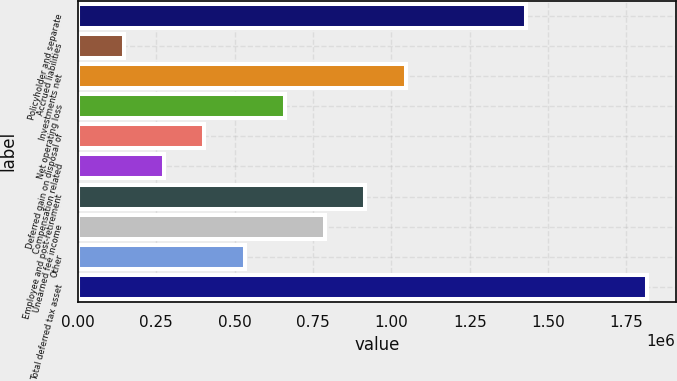Convert chart to OTSL. <chart><loc_0><loc_0><loc_500><loc_500><bar_chart><fcel>Policyholder and separate<fcel>Accrued liabilities<fcel>Investments net<fcel>Net operating loss<fcel>Deferred gain on disposal of<fcel>Compensation related<fcel>Employee and post-retirement<fcel>Unearned fee income<fcel>Other<fcel>Total deferred tax asset<nl><fcel>1.43103e+06<fcel>146606<fcel>1.0457e+06<fcel>660376<fcel>403491<fcel>275049<fcel>917260<fcel>788818<fcel>531933<fcel>1.81636e+06<nl></chart> 